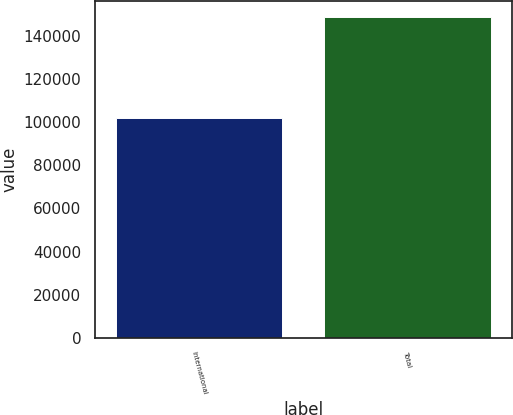Convert chart. <chart><loc_0><loc_0><loc_500><loc_500><bar_chart><fcel>International<fcel>Total<nl><fcel>102146<fcel>148574<nl></chart> 